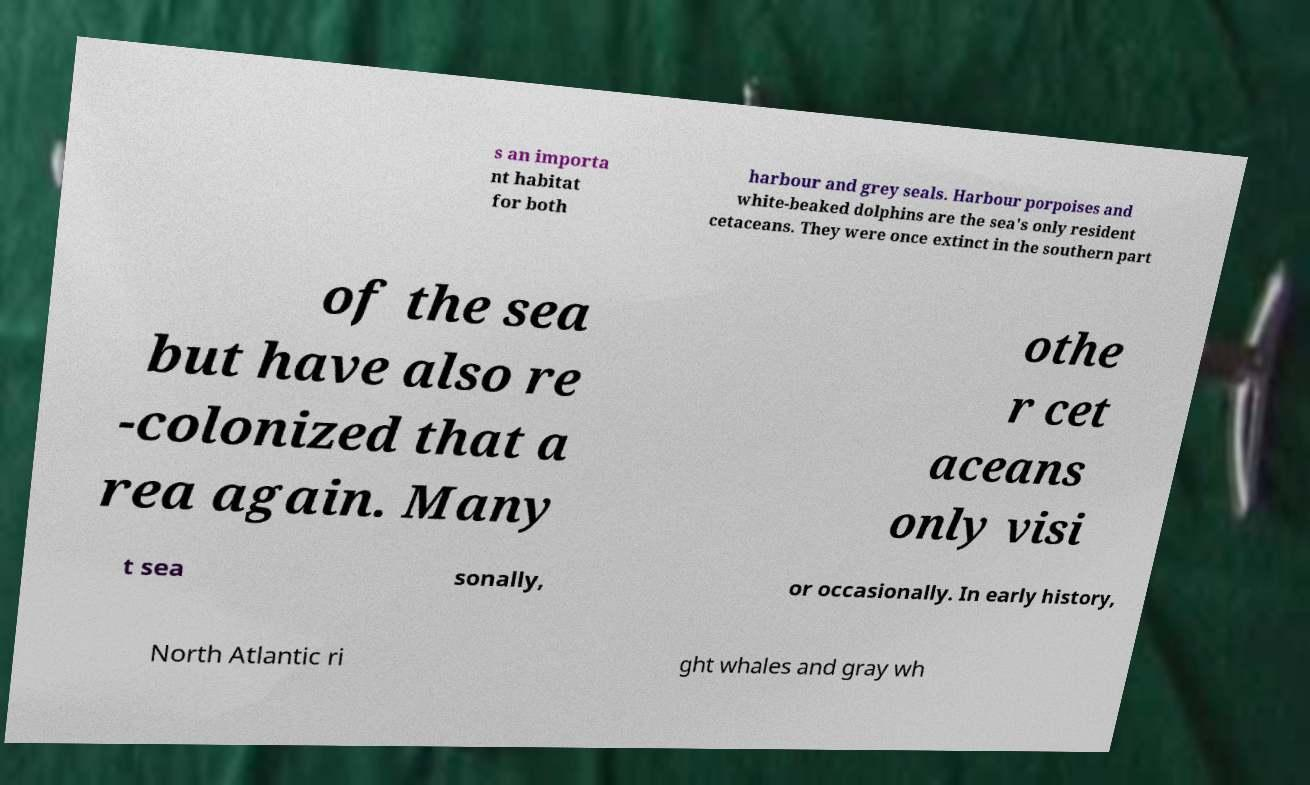Please identify and transcribe the text found in this image. s an importa nt habitat for both harbour and grey seals. Harbour porpoises and white-beaked dolphins are the sea's only resident cetaceans. They were once extinct in the southern part of the sea but have also re -colonized that a rea again. Many othe r cet aceans only visi t sea sonally, or occasionally. In early history, North Atlantic ri ght whales and gray wh 